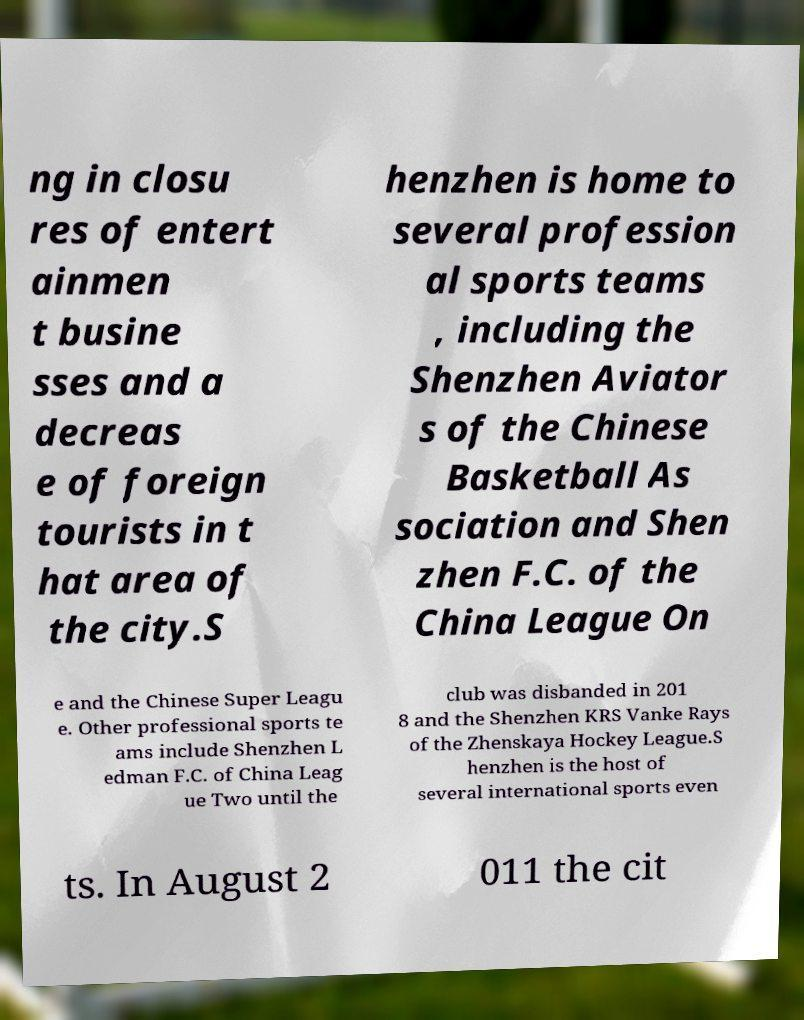There's text embedded in this image that I need extracted. Can you transcribe it verbatim? ng in closu res of entert ainmen t busine sses and a decreas e of foreign tourists in t hat area of the city.S henzhen is home to several profession al sports teams , including the Shenzhen Aviator s of the Chinese Basketball As sociation and Shen zhen F.C. of the China League On e and the Chinese Super Leagu e. Other professional sports te ams include Shenzhen L edman F.C. of China Leag ue Two until the club was disbanded in 201 8 and the Shenzhen KRS Vanke Rays of the Zhenskaya Hockey League.S henzhen is the host of several international sports even ts. In August 2 011 the cit 